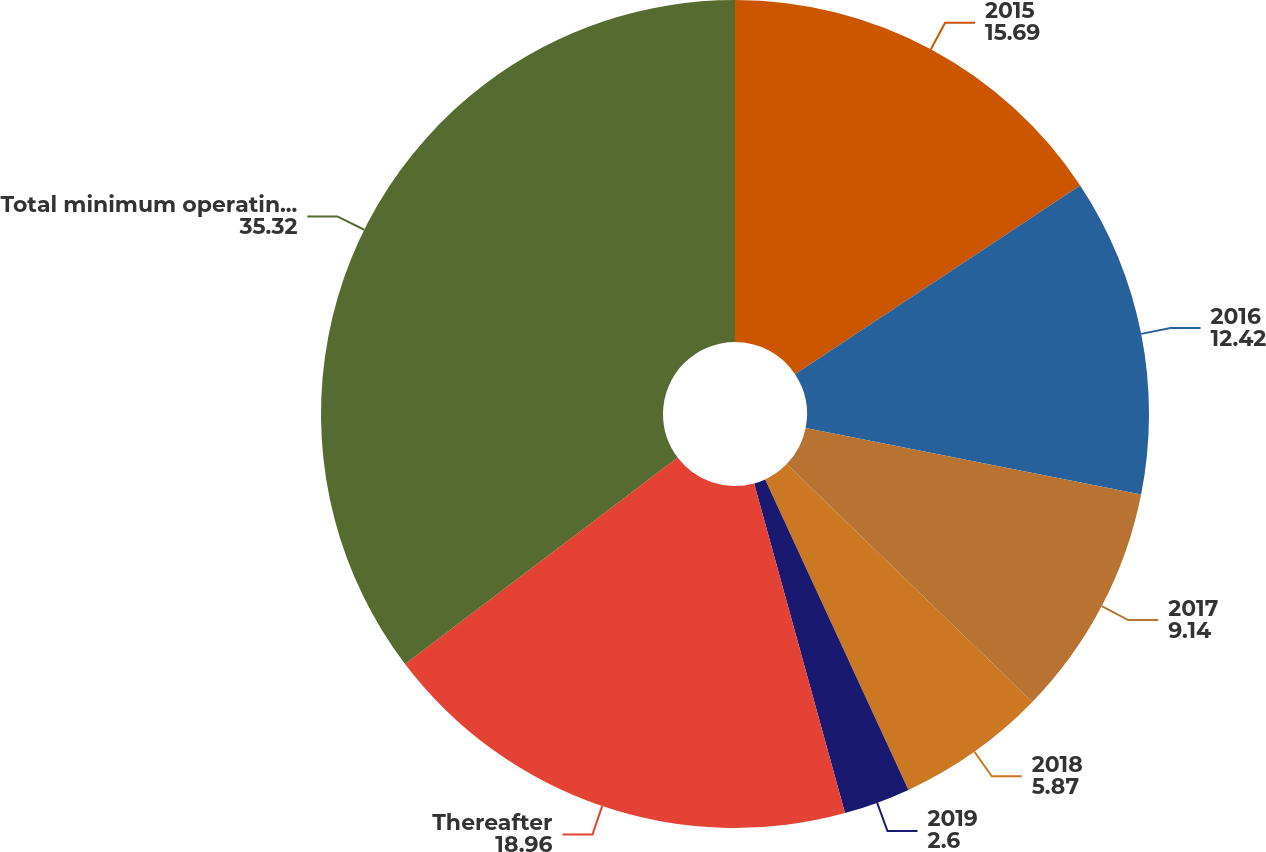Convert chart. <chart><loc_0><loc_0><loc_500><loc_500><pie_chart><fcel>2015<fcel>2016<fcel>2017<fcel>2018<fcel>2019<fcel>Thereafter<fcel>Total minimum operating lease<nl><fcel>15.69%<fcel>12.42%<fcel>9.14%<fcel>5.87%<fcel>2.6%<fcel>18.96%<fcel>35.32%<nl></chart> 